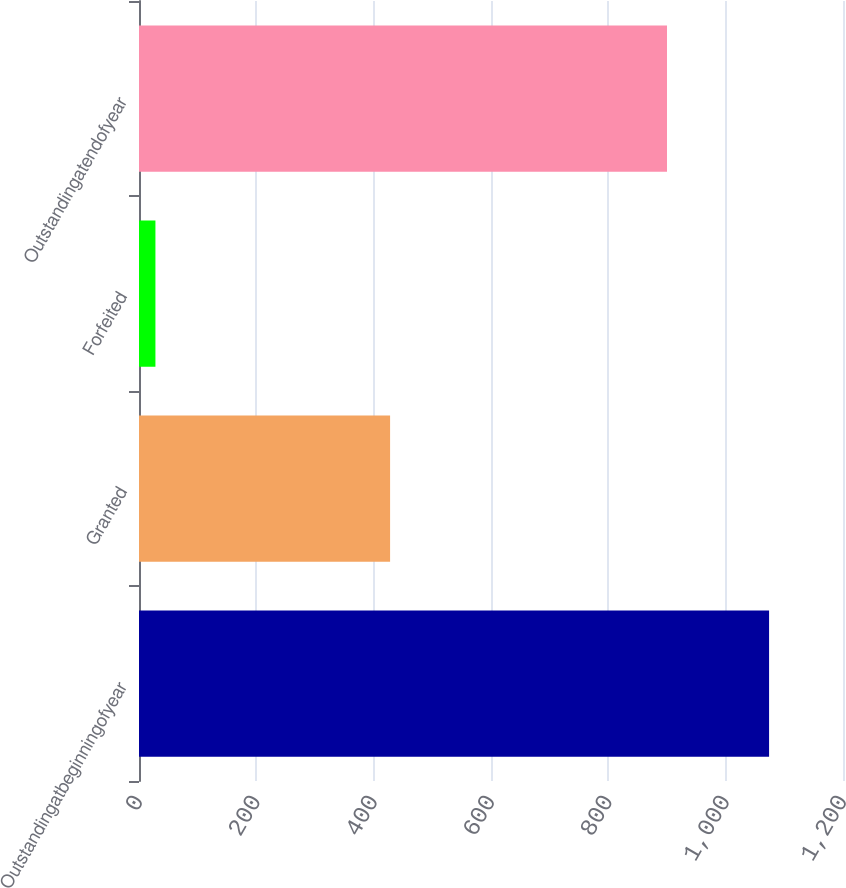Convert chart to OTSL. <chart><loc_0><loc_0><loc_500><loc_500><bar_chart><fcel>Outstandingatbeginningofyear<fcel>Granted<fcel>Forfeited<fcel>Outstandingatendofyear<nl><fcel>1074<fcel>428<fcel>28<fcel>900<nl></chart> 